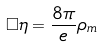<formula> <loc_0><loc_0><loc_500><loc_500>\Box \eta = \frac { 8 \pi } { e } \rho _ { m }</formula> 